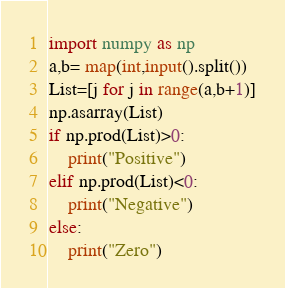<code> <loc_0><loc_0><loc_500><loc_500><_Python_>import numpy as np
a,b= map(int,input().split())
List=[j for j in range(a,b+1)]
np.asarray(List)
if np.prod(List)>0:
    print("Positive")
elif np.prod(List)<0:
    print("Negative")
else:
    print("Zero")</code> 